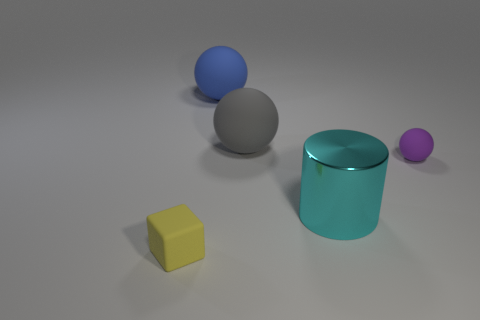Subtract all blue rubber balls. How many balls are left? 2 Subtract 2 balls. How many balls are left? 1 Add 2 small green metal blocks. How many objects exist? 7 Subtract all blue balls. How many balls are left? 2 Subtract all yellow cylinders. How many gray balls are left? 1 Subtract all cylinders. How many objects are left? 4 Subtract all green spheres. Subtract all yellow cylinders. How many spheres are left? 3 Subtract all large cyan shiny things. Subtract all purple rubber spheres. How many objects are left? 3 Add 4 yellow matte objects. How many yellow matte objects are left? 5 Add 4 gray matte things. How many gray matte things exist? 5 